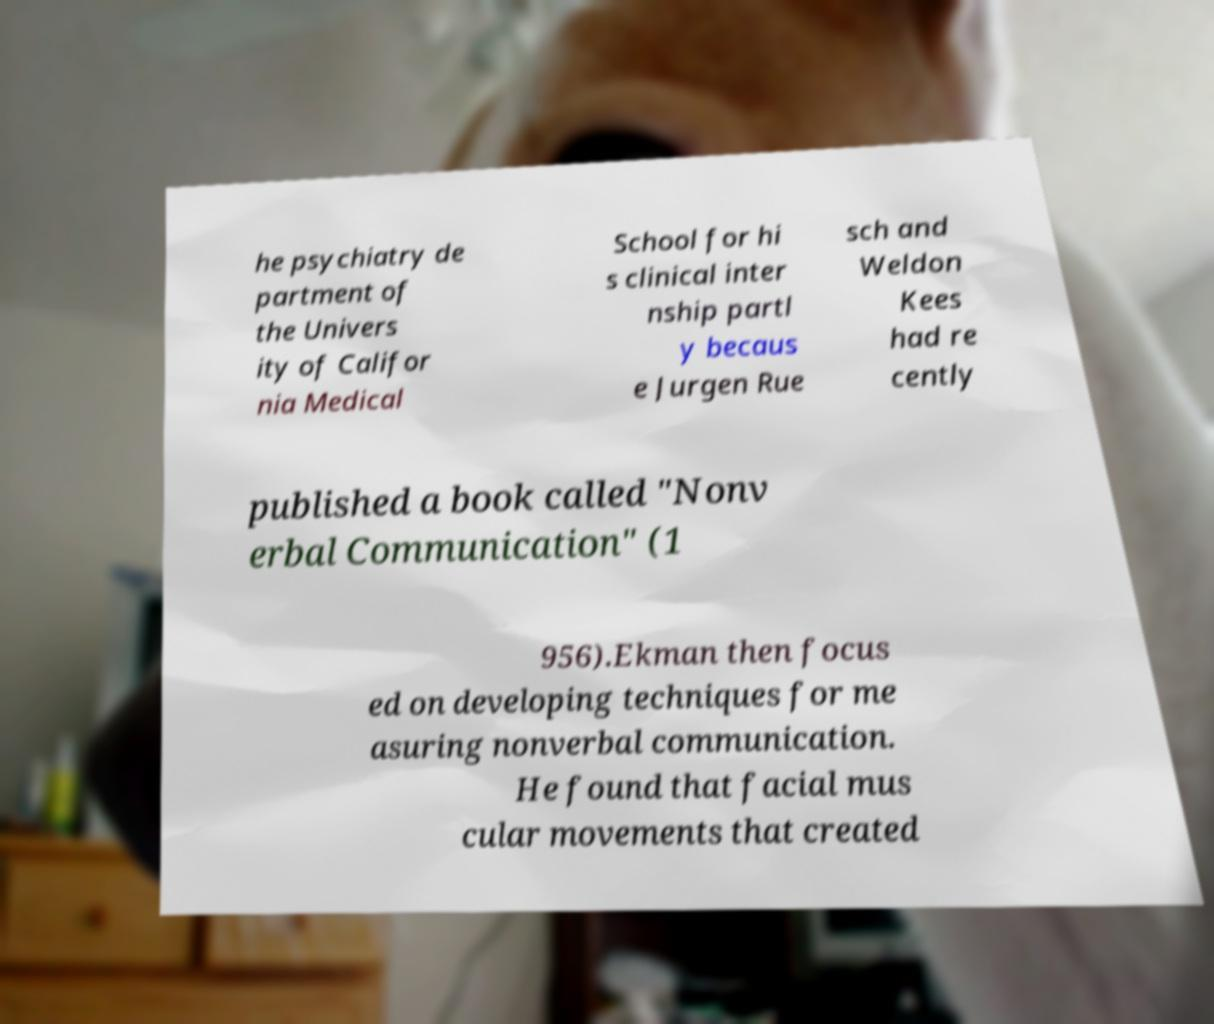Can you read and provide the text displayed in the image?This photo seems to have some interesting text. Can you extract and type it out for me? he psychiatry de partment of the Univers ity of Califor nia Medical School for hi s clinical inter nship partl y becaus e Jurgen Rue sch and Weldon Kees had re cently published a book called "Nonv erbal Communication" (1 956).Ekman then focus ed on developing techniques for me asuring nonverbal communication. He found that facial mus cular movements that created 